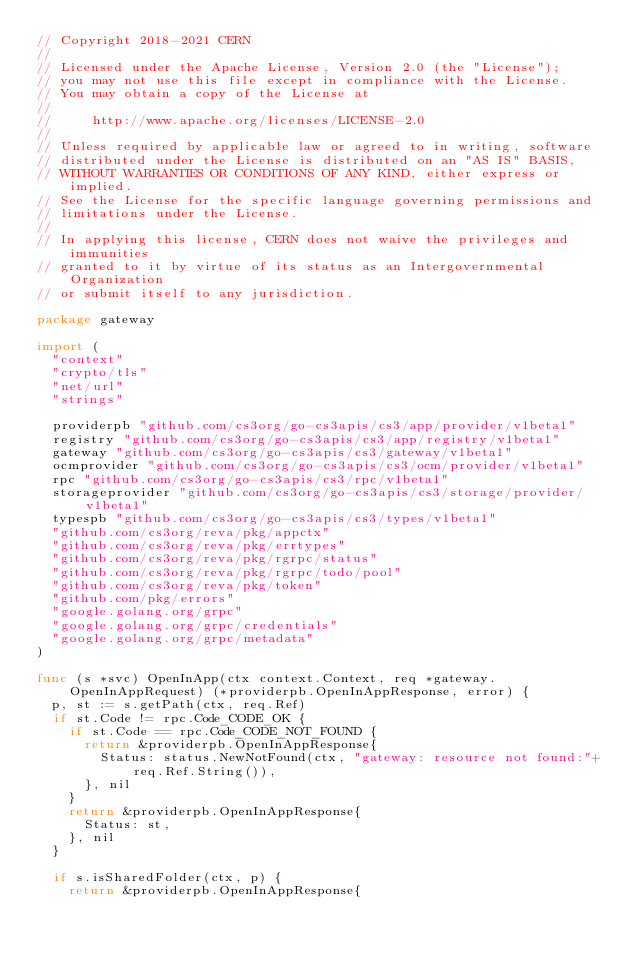<code> <loc_0><loc_0><loc_500><loc_500><_Go_>// Copyright 2018-2021 CERN
//
// Licensed under the Apache License, Version 2.0 (the "License");
// you may not use this file except in compliance with the License.
// You may obtain a copy of the License at
//
//     http://www.apache.org/licenses/LICENSE-2.0
//
// Unless required by applicable law or agreed to in writing, software
// distributed under the License is distributed on an "AS IS" BASIS,
// WITHOUT WARRANTIES OR CONDITIONS OF ANY KIND, either express or implied.
// See the License for the specific language governing permissions and
// limitations under the License.
//
// In applying this license, CERN does not waive the privileges and immunities
// granted to it by virtue of its status as an Intergovernmental Organization
// or submit itself to any jurisdiction.

package gateway

import (
	"context"
	"crypto/tls"
	"net/url"
	"strings"

	providerpb "github.com/cs3org/go-cs3apis/cs3/app/provider/v1beta1"
	registry "github.com/cs3org/go-cs3apis/cs3/app/registry/v1beta1"
	gateway "github.com/cs3org/go-cs3apis/cs3/gateway/v1beta1"
	ocmprovider "github.com/cs3org/go-cs3apis/cs3/ocm/provider/v1beta1"
	rpc "github.com/cs3org/go-cs3apis/cs3/rpc/v1beta1"
	storageprovider "github.com/cs3org/go-cs3apis/cs3/storage/provider/v1beta1"
	typespb "github.com/cs3org/go-cs3apis/cs3/types/v1beta1"
	"github.com/cs3org/reva/pkg/appctx"
	"github.com/cs3org/reva/pkg/errtypes"
	"github.com/cs3org/reva/pkg/rgrpc/status"
	"github.com/cs3org/reva/pkg/rgrpc/todo/pool"
	"github.com/cs3org/reva/pkg/token"
	"github.com/pkg/errors"
	"google.golang.org/grpc"
	"google.golang.org/grpc/credentials"
	"google.golang.org/grpc/metadata"
)

func (s *svc) OpenInApp(ctx context.Context, req *gateway.OpenInAppRequest) (*providerpb.OpenInAppResponse, error) {
	p, st := s.getPath(ctx, req.Ref)
	if st.Code != rpc.Code_CODE_OK {
		if st.Code == rpc.Code_CODE_NOT_FOUND {
			return &providerpb.OpenInAppResponse{
				Status: status.NewNotFound(ctx, "gateway: resource not found:"+req.Ref.String()),
			}, nil
		}
		return &providerpb.OpenInAppResponse{
			Status: st,
		}, nil
	}

	if s.isSharedFolder(ctx, p) {
		return &providerpb.OpenInAppResponse{</code> 